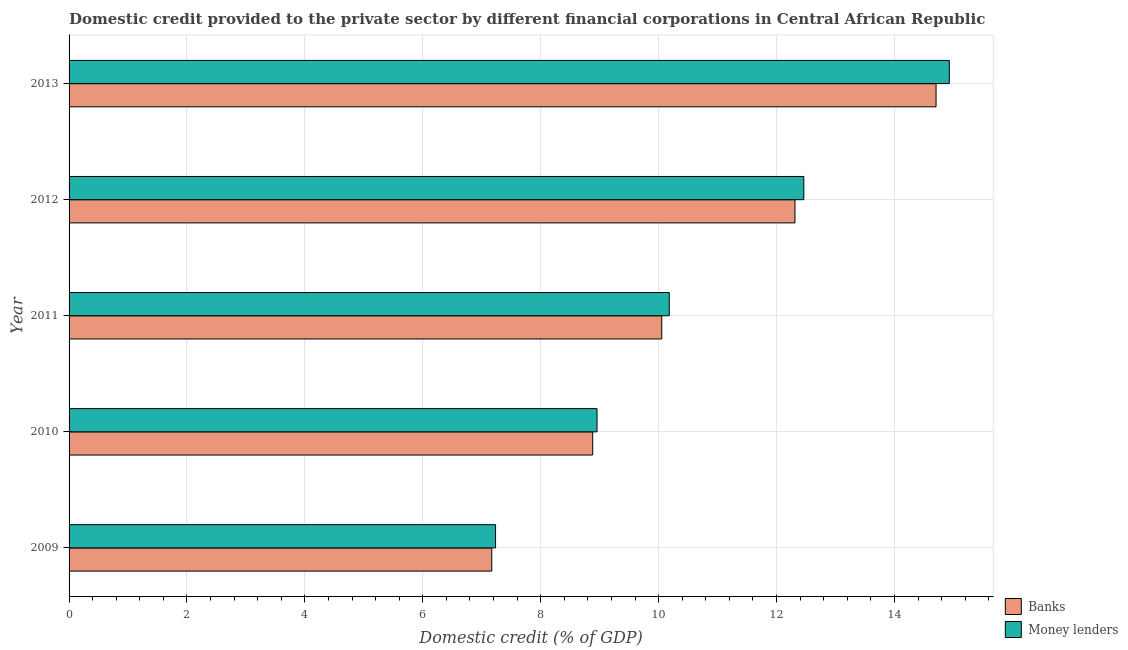Are the number of bars per tick equal to the number of legend labels?
Your answer should be compact. Yes. Are the number of bars on each tick of the Y-axis equal?
Make the answer very short. Yes. In how many cases, is the number of bars for a given year not equal to the number of legend labels?
Provide a succinct answer. 0. What is the domestic credit provided by money lenders in 2011?
Ensure brevity in your answer.  10.18. Across all years, what is the maximum domestic credit provided by banks?
Keep it short and to the point. 14.71. Across all years, what is the minimum domestic credit provided by money lenders?
Give a very brief answer. 7.23. In which year was the domestic credit provided by money lenders maximum?
Your answer should be very brief. 2013. What is the total domestic credit provided by money lenders in the graph?
Offer a very short reply. 53.76. What is the difference between the domestic credit provided by money lenders in 2009 and that in 2013?
Offer a terse response. -7.7. What is the difference between the domestic credit provided by money lenders in 2009 and the domestic credit provided by banks in 2010?
Keep it short and to the point. -1.65. What is the average domestic credit provided by money lenders per year?
Your answer should be compact. 10.75. In the year 2011, what is the difference between the domestic credit provided by money lenders and domestic credit provided by banks?
Give a very brief answer. 0.13. In how many years, is the domestic credit provided by money lenders greater than 11.6 %?
Provide a succinct answer. 2. What is the ratio of the domestic credit provided by money lenders in 2011 to that in 2013?
Provide a short and direct response. 0.68. Is the domestic credit provided by money lenders in 2009 less than that in 2010?
Give a very brief answer. Yes. Is the difference between the domestic credit provided by money lenders in 2009 and 2010 greater than the difference between the domestic credit provided by banks in 2009 and 2010?
Provide a short and direct response. No. What is the difference between the highest and the second highest domestic credit provided by money lenders?
Offer a very short reply. 2.47. In how many years, is the domestic credit provided by money lenders greater than the average domestic credit provided by money lenders taken over all years?
Offer a very short reply. 2. What does the 1st bar from the top in 2009 represents?
Offer a terse response. Money lenders. What does the 1st bar from the bottom in 2009 represents?
Ensure brevity in your answer.  Banks. What is the difference between two consecutive major ticks on the X-axis?
Your answer should be compact. 2. Does the graph contain any zero values?
Offer a terse response. No. Where does the legend appear in the graph?
Provide a short and direct response. Bottom right. How many legend labels are there?
Provide a short and direct response. 2. What is the title of the graph?
Provide a succinct answer. Domestic credit provided to the private sector by different financial corporations in Central African Republic. Does "From production" appear as one of the legend labels in the graph?
Give a very brief answer. No. What is the label or title of the X-axis?
Provide a short and direct response. Domestic credit (% of GDP). What is the label or title of the Y-axis?
Give a very brief answer. Year. What is the Domestic credit (% of GDP) of Banks in 2009?
Offer a terse response. 7.17. What is the Domestic credit (% of GDP) of Money lenders in 2009?
Keep it short and to the point. 7.23. What is the Domestic credit (% of GDP) of Banks in 2010?
Provide a short and direct response. 8.88. What is the Domestic credit (% of GDP) of Money lenders in 2010?
Offer a very short reply. 8.96. What is the Domestic credit (% of GDP) of Banks in 2011?
Your answer should be compact. 10.05. What is the Domestic credit (% of GDP) of Money lenders in 2011?
Provide a short and direct response. 10.18. What is the Domestic credit (% of GDP) of Banks in 2012?
Keep it short and to the point. 12.31. What is the Domestic credit (% of GDP) of Money lenders in 2012?
Give a very brief answer. 12.46. What is the Domestic credit (% of GDP) in Banks in 2013?
Your answer should be very brief. 14.71. What is the Domestic credit (% of GDP) of Money lenders in 2013?
Your answer should be very brief. 14.93. Across all years, what is the maximum Domestic credit (% of GDP) of Banks?
Keep it short and to the point. 14.71. Across all years, what is the maximum Domestic credit (% of GDP) in Money lenders?
Offer a terse response. 14.93. Across all years, what is the minimum Domestic credit (% of GDP) of Banks?
Offer a very short reply. 7.17. Across all years, what is the minimum Domestic credit (% of GDP) of Money lenders?
Offer a terse response. 7.23. What is the total Domestic credit (% of GDP) of Banks in the graph?
Keep it short and to the point. 53.12. What is the total Domestic credit (% of GDP) in Money lenders in the graph?
Your answer should be very brief. 53.76. What is the difference between the Domestic credit (% of GDP) of Banks in 2009 and that in 2010?
Make the answer very short. -1.71. What is the difference between the Domestic credit (% of GDP) of Money lenders in 2009 and that in 2010?
Your response must be concise. -1.72. What is the difference between the Domestic credit (% of GDP) in Banks in 2009 and that in 2011?
Keep it short and to the point. -2.88. What is the difference between the Domestic credit (% of GDP) of Money lenders in 2009 and that in 2011?
Ensure brevity in your answer.  -2.95. What is the difference between the Domestic credit (% of GDP) in Banks in 2009 and that in 2012?
Offer a terse response. -5.14. What is the difference between the Domestic credit (% of GDP) in Money lenders in 2009 and that in 2012?
Provide a succinct answer. -5.23. What is the difference between the Domestic credit (% of GDP) in Banks in 2009 and that in 2013?
Make the answer very short. -7.54. What is the difference between the Domestic credit (% of GDP) of Money lenders in 2009 and that in 2013?
Your answer should be compact. -7.7. What is the difference between the Domestic credit (% of GDP) of Banks in 2010 and that in 2011?
Offer a very short reply. -1.17. What is the difference between the Domestic credit (% of GDP) in Money lenders in 2010 and that in 2011?
Your response must be concise. -1.23. What is the difference between the Domestic credit (% of GDP) in Banks in 2010 and that in 2012?
Give a very brief answer. -3.43. What is the difference between the Domestic credit (% of GDP) in Money lenders in 2010 and that in 2012?
Provide a succinct answer. -3.51. What is the difference between the Domestic credit (% of GDP) in Banks in 2010 and that in 2013?
Offer a very short reply. -5.82. What is the difference between the Domestic credit (% of GDP) in Money lenders in 2010 and that in 2013?
Your response must be concise. -5.98. What is the difference between the Domestic credit (% of GDP) of Banks in 2011 and that in 2012?
Give a very brief answer. -2.26. What is the difference between the Domestic credit (% of GDP) of Money lenders in 2011 and that in 2012?
Give a very brief answer. -2.28. What is the difference between the Domestic credit (% of GDP) in Banks in 2011 and that in 2013?
Your response must be concise. -4.65. What is the difference between the Domestic credit (% of GDP) of Money lenders in 2011 and that in 2013?
Give a very brief answer. -4.75. What is the difference between the Domestic credit (% of GDP) in Banks in 2012 and that in 2013?
Give a very brief answer. -2.39. What is the difference between the Domestic credit (% of GDP) in Money lenders in 2012 and that in 2013?
Keep it short and to the point. -2.47. What is the difference between the Domestic credit (% of GDP) in Banks in 2009 and the Domestic credit (% of GDP) in Money lenders in 2010?
Offer a terse response. -1.79. What is the difference between the Domestic credit (% of GDP) in Banks in 2009 and the Domestic credit (% of GDP) in Money lenders in 2011?
Provide a succinct answer. -3.01. What is the difference between the Domestic credit (% of GDP) in Banks in 2009 and the Domestic credit (% of GDP) in Money lenders in 2012?
Offer a very short reply. -5.29. What is the difference between the Domestic credit (% of GDP) of Banks in 2009 and the Domestic credit (% of GDP) of Money lenders in 2013?
Provide a short and direct response. -7.76. What is the difference between the Domestic credit (% of GDP) in Banks in 2010 and the Domestic credit (% of GDP) in Money lenders in 2011?
Ensure brevity in your answer.  -1.3. What is the difference between the Domestic credit (% of GDP) in Banks in 2010 and the Domestic credit (% of GDP) in Money lenders in 2012?
Keep it short and to the point. -3.58. What is the difference between the Domestic credit (% of GDP) in Banks in 2010 and the Domestic credit (% of GDP) in Money lenders in 2013?
Your response must be concise. -6.05. What is the difference between the Domestic credit (% of GDP) in Banks in 2011 and the Domestic credit (% of GDP) in Money lenders in 2012?
Give a very brief answer. -2.41. What is the difference between the Domestic credit (% of GDP) of Banks in 2011 and the Domestic credit (% of GDP) of Money lenders in 2013?
Your answer should be very brief. -4.88. What is the difference between the Domestic credit (% of GDP) in Banks in 2012 and the Domestic credit (% of GDP) in Money lenders in 2013?
Ensure brevity in your answer.  -2.62. What is the average Domestic credit (% of GDP) of Banks per year?
Your response must be concise. 10.62. What is the average Domestic credit (% of GDP) of Money lenders per year?
Offer a terse response. 10.75. In the year 2009, what is the difference between the Domestic credit (% of GDP) in Banks and Domestic credit (% of GDP) in Money lenders?
Keep it short and to the point. -0.06. In the year 2010, what is the difference between the Domestic credit (% of GDP) of Banks and Domestic credit (% of GDP) of Money lenders?
Offer a very short reply. -0.07. In the year 2011, what is the difference between the Domestic credit (% of GDP) of Banks and Domestic credit (% of GDP) of Money lenders?
Provide a succinct answer. -0.13. In the year 2012, what is the difference between the Domestic credit (% of GDP) of Banks and Domestic credit (% of GDP) of Money lenders?
Ensure brevity in your answer.  -0.15. In the year 2013, what is the difference between the Domestic credit (% of GDP) of Banks and Domestic credit (% of GDP) of Money lenders?
Provide a short and direct response. -0.22. What is the ratio of the Domestic credit (% of GDP) in Banks in 2009 to that in 2010?
Provide a short and direct response. 0.81. What is the ratio of the Domestic credit (% of GDP) in Money lenders in 2009 to that in 2010?
Give a very brief answer. 0.81. What is the ratio of the Domestic credit (% of GDP) of Banks in 2009 to that in 2011?
Offer a very short reply. 0.71. What is the ratio of the Domestic credit (% of GDP) of Money lenders in 2009 to that in 2011?
Your answer should be very brief. 0.71. What is the ratio of the Domestic credit (% of GDP) of Banks in 2009 to that in 2012?
Your answer should be compact. 0.58. What is the ratio of the Domestic credit (% of GDP) in Money lenders in 2009 to that in 2012?
Provide a short and direct response. 0.58. What is the ratio of the Domestic credit (% of GDP) of Banks in 2009 to that in 2013?
Your answer should be very brief. 0.49. What is the ratio of the Domestic credit (% of GDP) of Money lenders in 2009 to that in 2013?
Give a very brief answer. 0.48. What is the ratio of the Domestic credit (% of GDP) in Banks in 2010 to that in 2011?
Offer a terse response. 0.88. What is the ratio of the Domestic credit (% of GDP) in Money lenders in 2010 to that in 2011?
Provide a short and direct response. 0.88. What is the ratio of the Domestic credit (% of GDP) in Banks in 2010 to that in 2012?
Offer a very short reply. 0.72. What is the ratio of the Domestic credit (% of GDP) of Money lenders in 2010 to that in 2012?
Offer a terse response. 0.72. What is the ratio of the Domestic credit (% of GDP) of Banks in 2010 to that in 2013?
Offer a very short reply. 0.6. What is the ratio of the Domestic credit (% of GDP) of Money lenders in 2010 to that in 2013?
Offer a terse response. 0.6. What is the ratio of the Domestic credit (% of GDP) of Banks in 2011 to that in 2012?
Provide a short and direct response. 0.82. What is the ratio of the Domestic credit (% of GDP) in Money lenders in 2011 to that in 2012?
Ensure brevity in your answer.  0.82. What is the ratio of the Domestic credit (% of GDP) of Banks in 2011 to that in 2013?
Offer a very short reply. 0.68. What is the ratio of the Domestic credit (% of GDP) in Money lenders in 2011 to that in 2013?
Your answer should be very brief. 0.68. What is the ratio of the Domestic credit (% of GDP) in Banks in 2012 to that in 2013?
Offer a very short reply. 0.84. What is the ratio of the Domestic credit (% of GDP) of Money lenders in 2012 to that in 2013?
Offer a terse response. 0.83. What is the difference between the highest and the second highest Domestic credit (% of GDP) of Banks?
Keep it short and to the point. 2.39. What is the difference between the highest and the second highest Domestic credit (% of GDP) of Money lenders?
Your answer should be very brief. 2.47. What is the difference between the highest and the lowest Domestic credit (% of GDP) in Banks?
Provide a short and direct response. 7.54. What is the difference between the highest and the lowest Domestic credit (% of GDP) in Money lenders?
Make the answer very short. 7.7. 